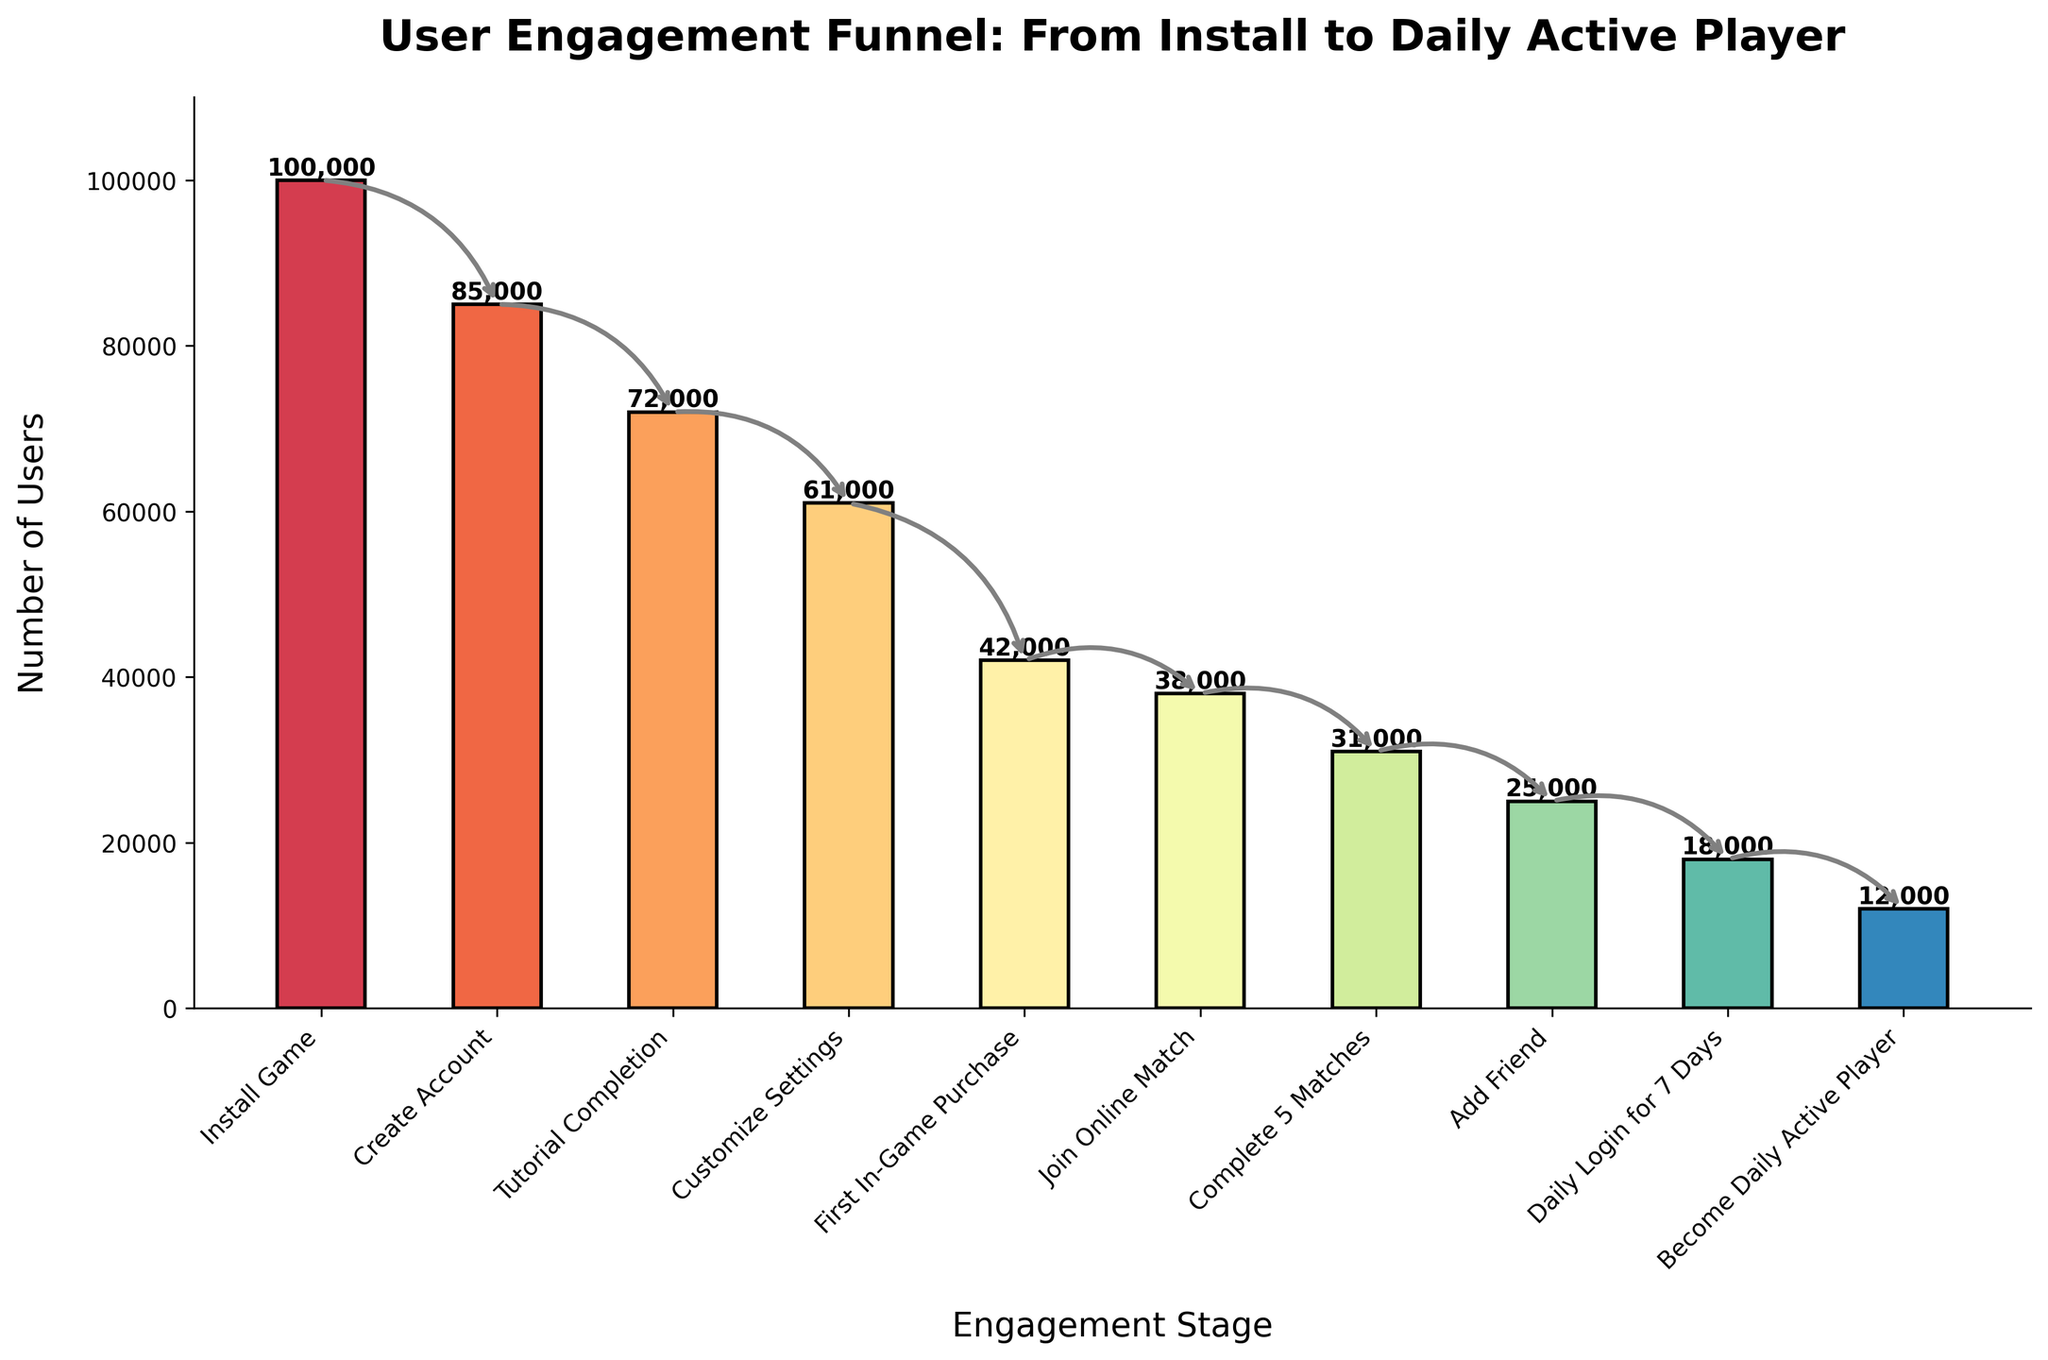What's the title of the chart? The title is displayed at the top center of the chart. It reads "User Engagement Funnel: From Install to Daily Active Player."
Answer: User Engagement Funnel: From Install to Daily Active Player What is the first stage in the funnel? The first stage in the funnel appears at the leftmost part of the x-axis, labeled with the text "Install Game."
Answer: Install Game How many users completed the "Tutorial Completion" stage? The bar corresponding to the "Tutorial Completion" stage shows the count of users as indicated by the height and the number on top of the bar.
Answer: 72,000 What is the total number of users that joined an online match and added a friend? To find the total, sum the users for the stages "Join Online Match" and "Add Friend." That is, 38,000 (Join Online Match) + 25,000 (Add Friend) = 63,000.
Answer: 63,000 What is the drop in user count from "Customize Settings" to "First In-Game Purchase"? Subtract the number of users in "First In-Game Purchase" from the number of users in "Customize Settings." That is, 61,000 (Customize Settings) - 42,000 (First In-Game Purchase) = 19,000.
Answer: 19,000 Which stage shows a larger drop in users, "Create Account" to "Tutorial Completion" or "Add Friend" to "Daily Login for 7 Days"? Calculate the drop for both transitions: 
1) "Create Account" to "Tutorial Completion" = 85,000 - 72,000 = 13,000 
2) "Add Friend" to "Daily Login for 7 Days" = 25,000 - 18,000 = 7,000 
The first transition has a larger drop.
Answer: Create Account to Tutorial Completion How many users became daily active players? The last stage "Become Daily Active Player" shows the number of users who reached this final stage. The count is displayed directly above the bar for this stage.
Answer: 12,000 What's the percentage of users who completed the tutorial compared to those who installed the game? Calculate the percentage by dividing the number of users who completed the tutorial by those who installed the game and then multiply by 100. That is, (72,000 / 100,000) × 100 = 72%.
Answer: 72% Out of users who joined an online match, what percentage didn't complete 5 matches? First find users who didn't complete 5 matches by subtracting those who completed 5 matches from those who joined an online match: 38,000 (Join Online Match) - 31,000 (Complete 5 Matches) = 7,000. Then calculate the percentage: (7,000 / 38,000) × 100 ≈ 18.4%.
Answer: 18.4% From the figure, what can you infer about user engagement and retention? The funnel shows a steady decline from one stage to the next, significantly dropping at each step. It highlights that while initial engagement is high, retaining users through advanced engagement stages like the first in-game purchase and daily activities is challenging.
Answer: Steady decline, significant drop at each step 